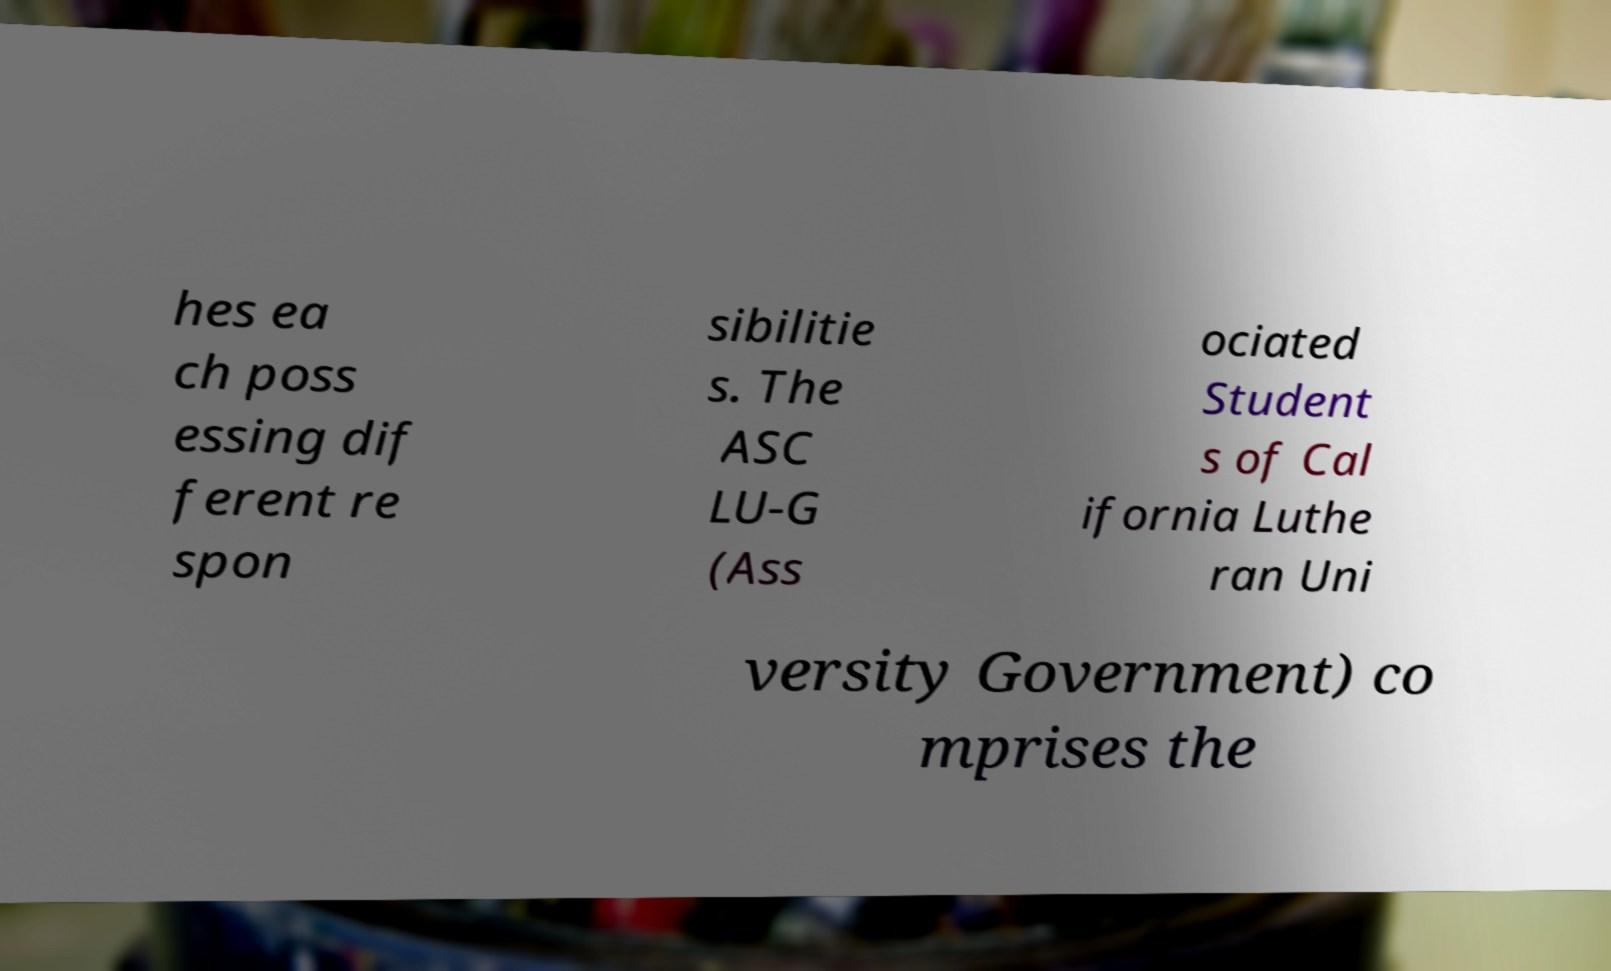Please identify and transcribe the text found in this image. hes ea ch poss essing dif ferent re spon sibilitie s. The ASC LU-G (Ass ociated Student s of Cal ifornia Luthe ran Uni versity Government) co mprises the 